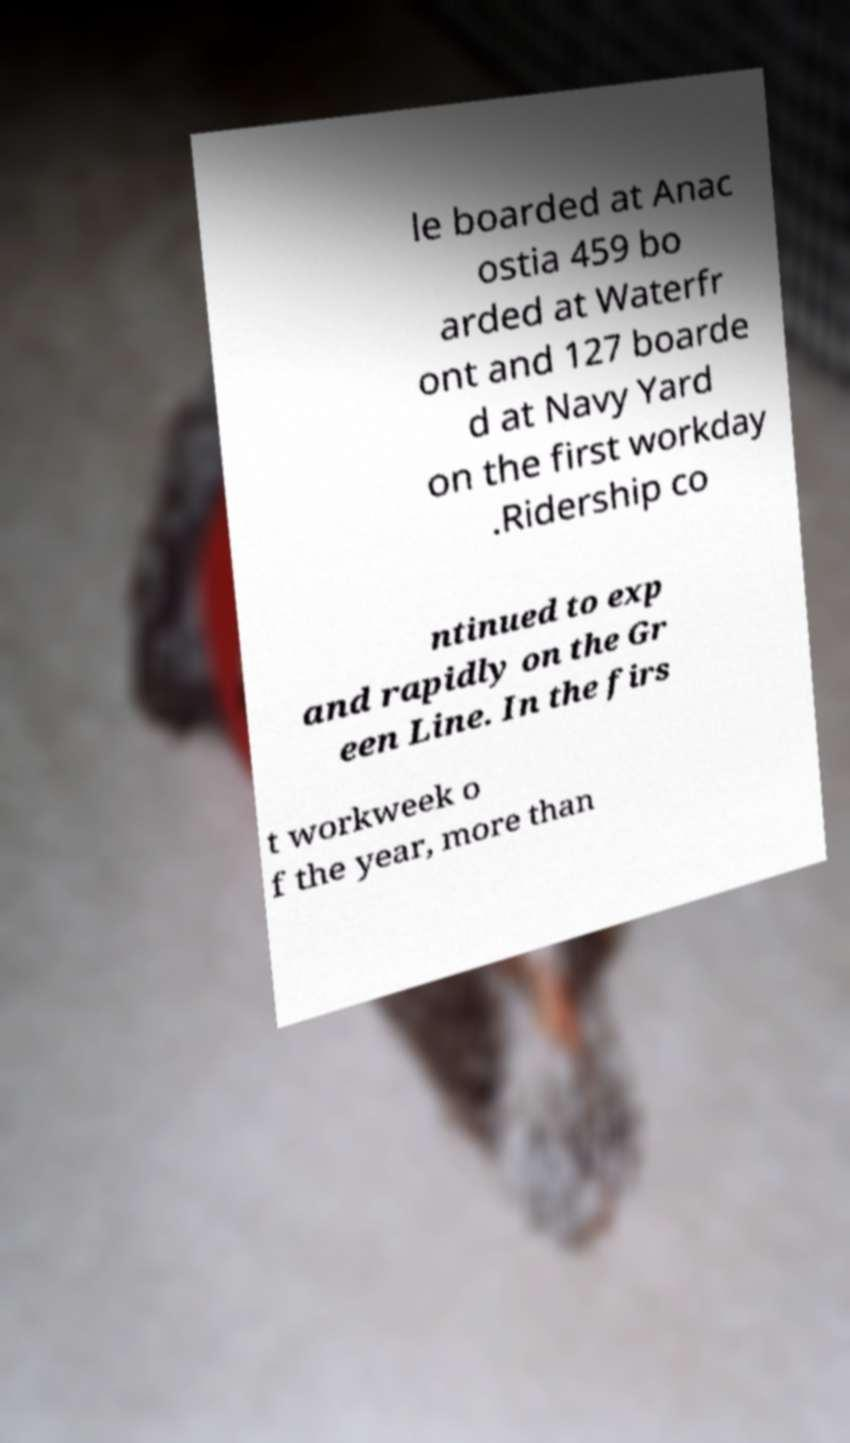I need the written content from this picture converted into text. Can you do that? le boarded at Anac ostia 459 bo arded at Waterfr ont and 127 boarde d at Navy Yard on the first workday .Ridership co ntinued to exp and rapidly on the Gr een Line. In the firs t workweek o f the year, more than 